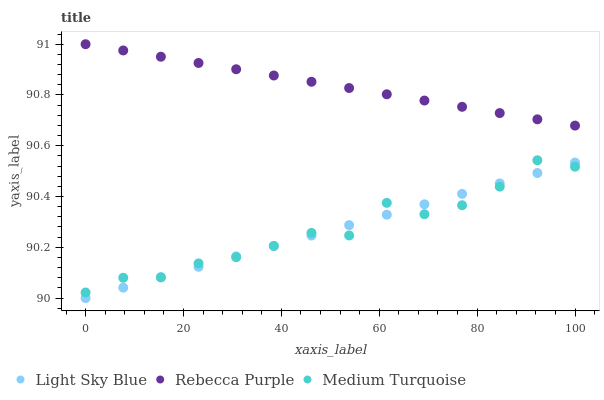Does Light Sky Blue have the minimum area under the curve?
Answer yes or no. Yes. Does Rebecca Purple have the maximum area under the curve?
Answer yes or no. Yes. Does Medium Turquoise have the minimum area under the curve?
Answer yes or no. No. Does Medium Turquoise have the maximum area under the curve?
Answer yes or no. No. Is Light Sky Blue the smoothest?
Answer yes or no. Yes. Is Medium Turquoise the roughest?
Answer yes or no. Yes. Is Rebecca Purple the smoothest?
Answer yes or no. No. Is Rebecca Purple the roughest?
Answer yes or no. No. Does Light Sky Blue have the lowest value?
Answer yes or no. Yes. Does Medium Turquoise have the lowest value?
Answer yes or no. No. Does Rebecca Purple have the highest value?
Answer yes or no. Yes. Does Medium Turquoise have the highest value?
Answer yes or no. No. Is Light Sky Blue less than Rebecca Purple?
Answer yes or no. Yes. Is Rebecca Purple greater than Medium Turquoise?
Answer yes or no. Yes. Does Light Sky Blue intersect Medium Turquoise?
Answer yes or no. Yes. Is Light Sky Blue less than Medium Turquoise?
Answer yes or no. No. Is Light Sky Blue greater than Medium Turquoise?
Answer yes or no. No. Does Light Sky Blue intersect Rebecca Purple?
Answer yes or no. No. 